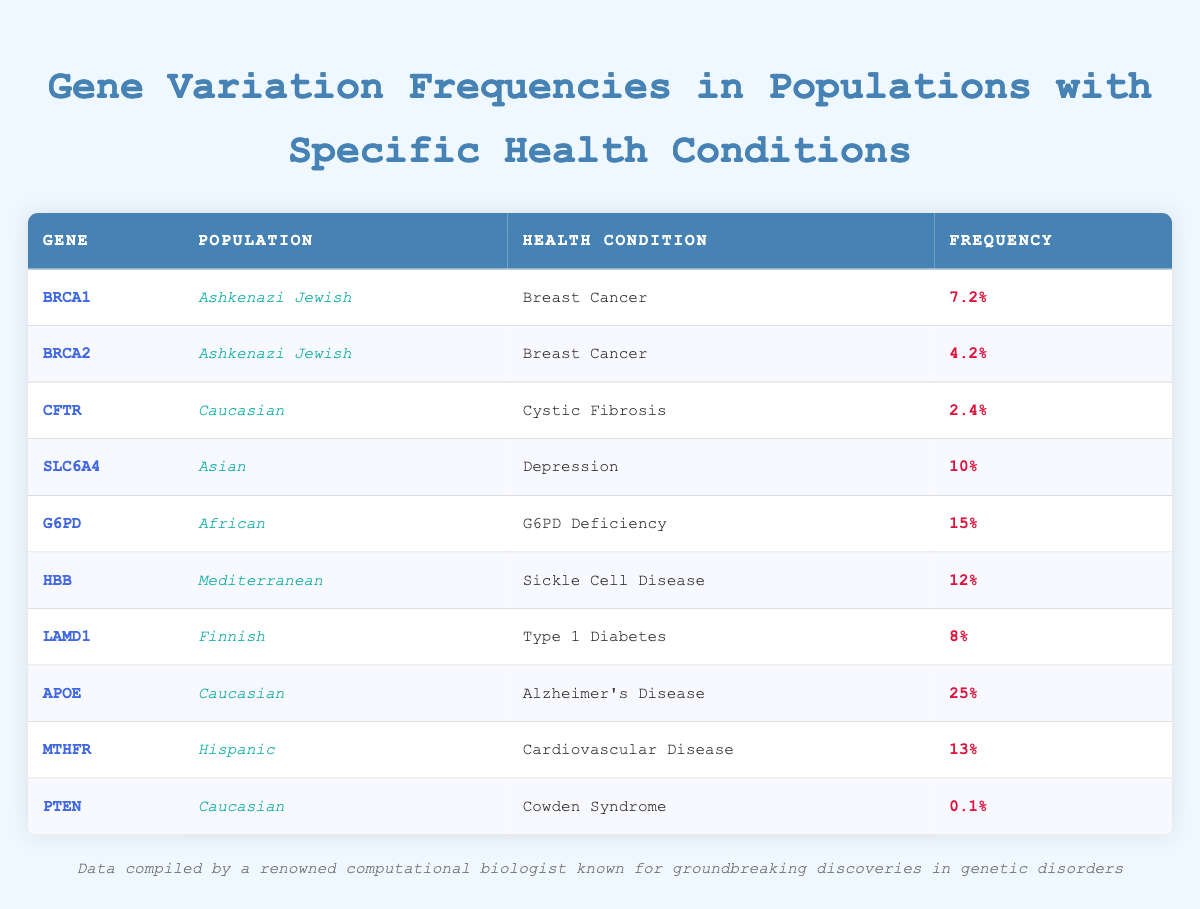What is the frequency of the BRCA1 gene variation in the Ashkenazi Jewish population? The table shows that the frequency of the BRCA1 gene variation in the Ashkenazi Jewish population is listed in its corresponding row as 0.072, or 7.2%.
Answer: 7.2% Which population has the highest frequency of gene variation for Alzheimer’s Disease? The table indicates that the frequency of the APOE gene variation for Alzheimer's Disease in the Caucasian population is 0.25, or 25%, which is higher than any other health condition listed in the table.
Answer: Caucasian Is the frequency of MTHFR gene variation higher in Hispanic populations than the frequency of CFTR gene variation in Caucasian populations? The MTHFR gene frequency in Hispanics is 0.13 (13%), while the CFTR gene frequency in Caucasians is 0.024 (2.4%). Since 0.13 is greater than 0.024, the frequency of MTHFR is indeed higher.
Answer: Yes What is the total frequency of gene variations for health conditions listed in the table? To find the total frequency, sum all individual frequencies: 0.072 + 0.042 + 0.024 + 0.10 + 0.15 + 0.12 + 0.08 + 0.25 + 0.13 + 0.001 = 0.272, which represents the combined frequencies across all health conditions.
Answer: 0.272 How many populations have gene variation frequencies above 0.1? By examining the table, the following populations have frequencies above 0.1: Asian (SLC6A4 - 0.1), African (G6PD - 0.15), Mediterranean (HBB - 0.12), Caucasian (APOE - 0.25), and Hispanic (MTHFR - 0.13). This totals to 5 populations.
Answer: 5 Which gene variation is associated with the lowest frequency, and what is that frequency? The lowest frequency in the table is for the PTEN gene variation associated with Cowden Syndrome, which is given as 0.001 or 0.1%.
Answer: 0.001 Is there a gene associated with Type 1 Diabetes at a higher frequency than 0.1? LAMD1 is the gene associated with Type 1 Diabetes, and its frequency is 0.08 (8%), which is not higher than 0.1. So, there is no gene associated with this condition above that threshold.
Answer: No When comparing frequencies, which health condition associated with a gene variation has the highest frequency in African populations? The health condition linked to the G6PD gene variation in African populations has the highest frequency listed at 0.15 (15%), as evidenced from the table.
Answer: G6PD Deficiency 